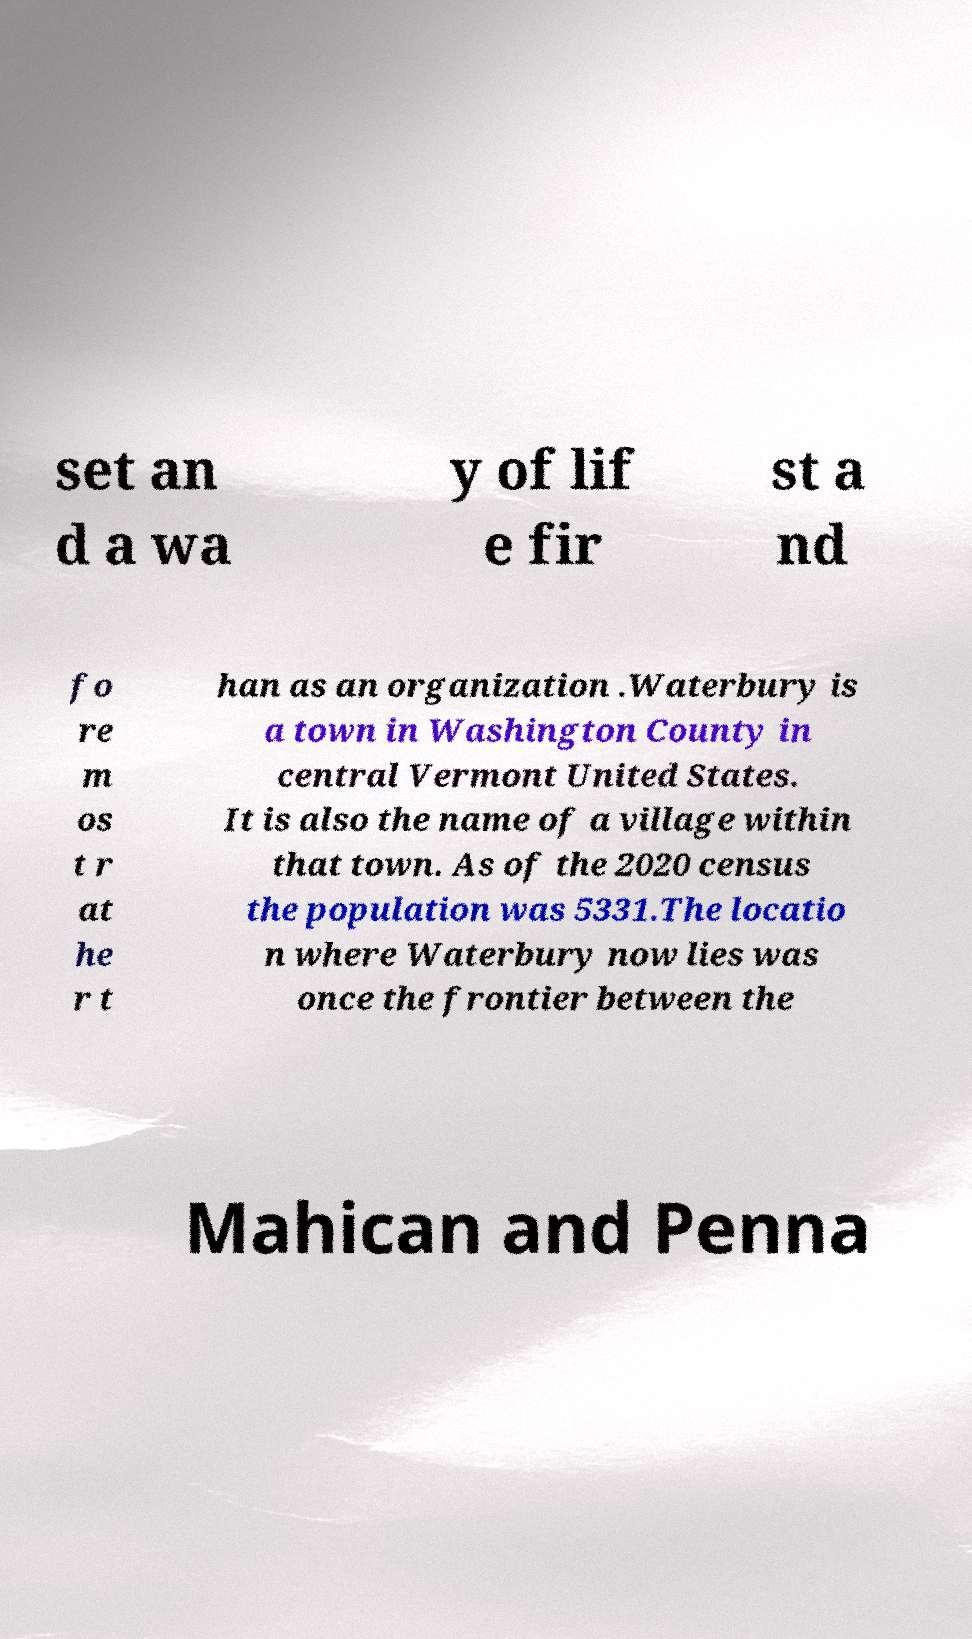There's text embedded in this image that I need extracted. Can you transcribe it verbatim? set an d a wa y of lif e fir st a nd fo re m os t r at he r t han as an organization .Waterbury is a town in Washington County in central Vermont United States. It is also the name of a village within that town. As of the 2020 census the population was 5331.The locatio n where Waterbury now lies was once the frontier between the Mahican and Penna 